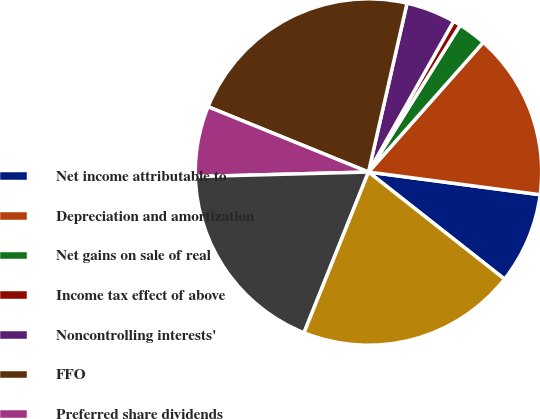<chart> <loc_0><loc_0><loc_500><loc_500><pie_chart><fcel>Net income attributable to<fcel>Depreciation and amortization<fcel>Net gains on sale of real<fcel>Income tax effect of above<fcel>Noncontrolling interests'<fcel>FFO<fcel>Preferred share dividends<fcel>FFO attributable to common<fcel>plus assumed conversions (1)<nl><fcel>8.52%<fcel>15.56%<fcel>2.65%<fcel>0.7%<fcel>4.61%<fcel>22.42%<fcel>6.57%<fcel>18.51%<fcel>20.46%<nl></chart> 